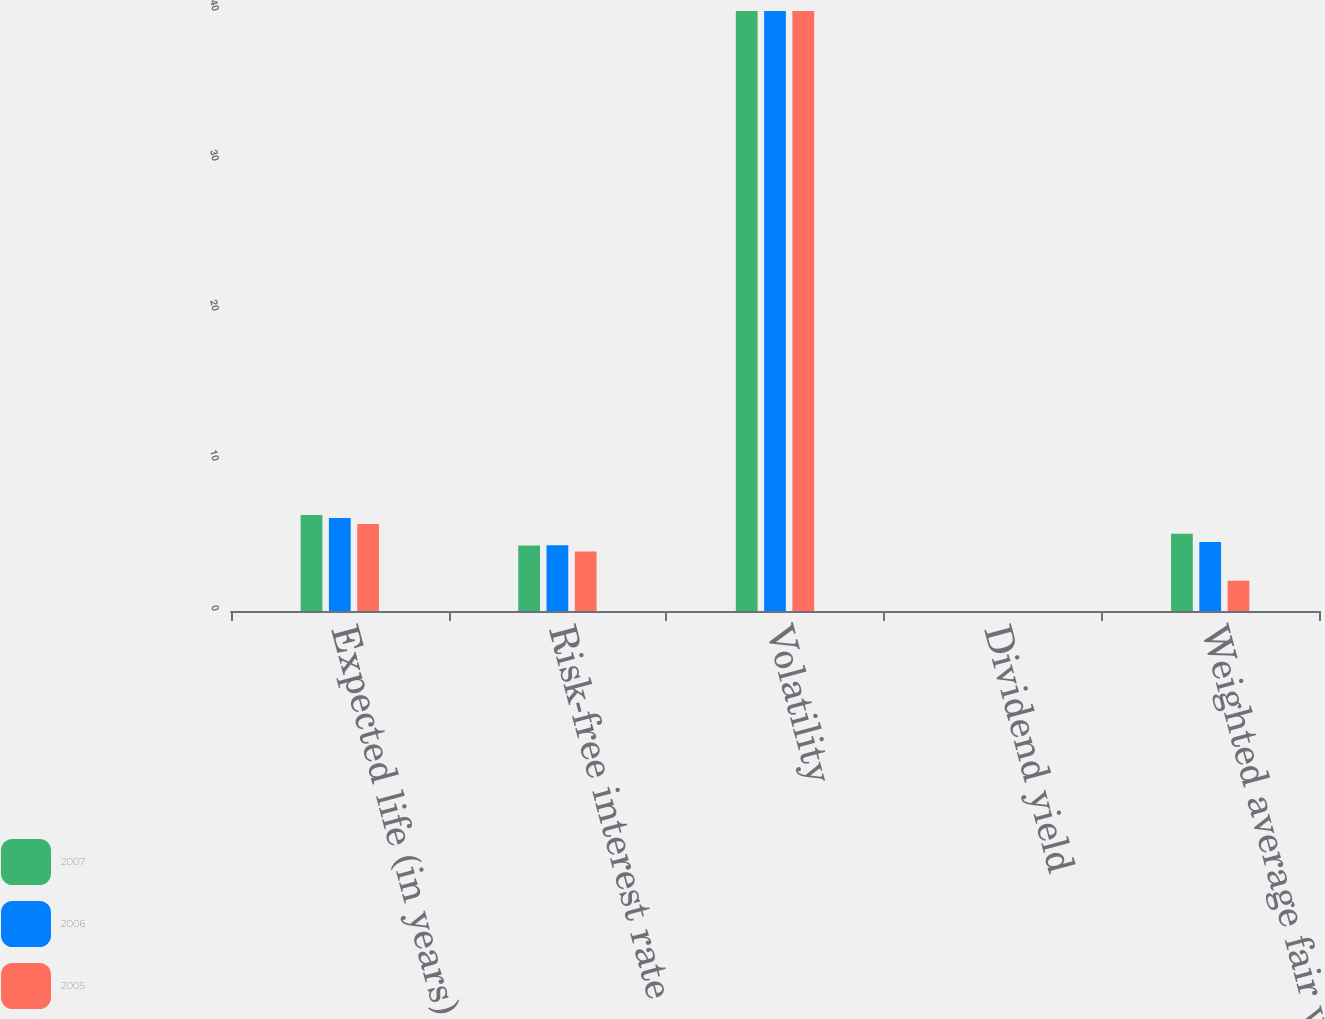Convert chart to OTSL. <chart><loc_0><loc_0><loc_500><loc_500><stacked_bar_chart><ecel><fcel>Expected life (in years)<fcel>Risk-free interest rate<fcel>Volatility<fcel>Dividend yield<fcel>Weighted average fair value of<nl><fcel>2007<fcel>6.4<fcel>4.37<fcel>40<fcel>0<fcel>5.15<nl><fcel>2006<fcel>6.2<fcel>4.38<fcel>40<fcel>0<fcel>4.6<nl><fcel>2005<fcel>5.8<fcel>3.96<fcel>40<fcel>0<fcel>2.02<nl></chart> 